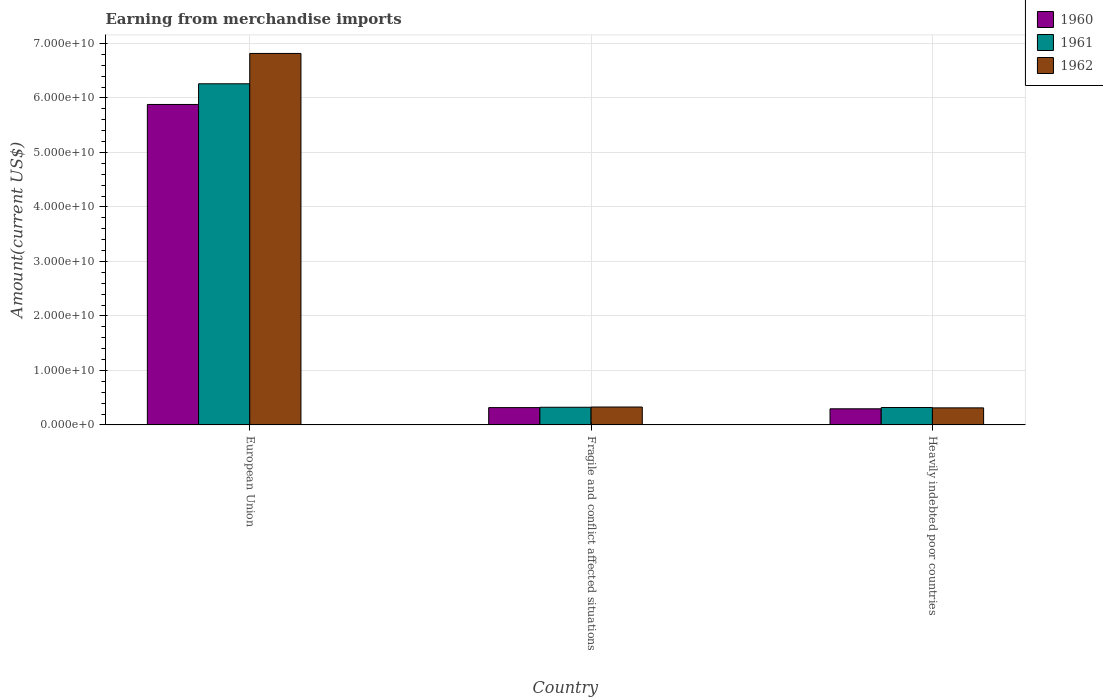How many groups of bars are there?
Your answer should be very brief. 3. Are the number of bars per tick equal to the number of legend labels?
Offer a very short reply. Yes. What is the amount earned from merchandise imports in 1962 in European Union?
Offer a terse response. 6.82e+1. Across all countries, what is the maximum amount earned from merchandise imports in 1960?
Keep it short and to the point. 5.88e+1. Across all countries, what is the minimum amount earned from merchandise imports in 1962?
Make the answer very short. 3.13e+09. In which country was the amount earned from merchandise imports in 1961 minimum?
Give a very brief answer. Heavily indebted poor countries. What is the total amount earned from merchandise imports in 1960 in the graph?
Your answer should be compact. 6.49e+1. What is the difference between the amount earned from merchandise imports in 1961 in European Union and that in Fragile and conflict affected situations?
Keep it short and to the point. 5.94e+1. What is the difference between the amount earned from merchandise imports in 1962 in European Union and the amount earned from merchandise imports in 1961 in Heavily indebted poor countries?
Provide a short and direct response. 6.50e+1. What is the average amount earned from merchandise imports in 1960 per country?
Your response must be concise. 2.16e+1. What is the difference between the amount earned from merchandise imports of/in 1962 and amount earned from merchandise imports of/in 1961 in European Union?
Keep it short and to the point. 5.56e+09. In how many countries, is the amount earned from merchandise imports in 1961 greater than 24000000000 US$?
Offer a terse response. 1. What is the ratio of the amount earned from merchandise imports in 1961 in European Union to that in Heavily indebted poor countries?
Offer a very short reply. 19.62. What is the difference between the highest and the second highest amount earned from merchandise imports in 1961?
Keep it short and to the point. -5.94e+1. What is the difference between the highest and the lowest amount earned from merchandise imports in 1961?
Give a very brief answer. 5.94e+1. Is it the case that in every country, the sum of the amount earned from merchandise imports in 1960 and amount earned from merchandise imports in 1962 is greater than the amount earned from merchandise imports in 1961?
Ensure brevity in your answer.  Yes. Are all the bars in the graph horizontal?
Keep it short and to the point. No. Does the graph contain any zero values?
Offer a terse response. No. Does the graph contain grids?
Your response must be concise. Yes. What is the title of the graph?
Offer a terse response. Earning from merchandise imports. What is the label or title of the Y-axis?
Your response must be concise. Amount(current US$). What is the Amount(current US$) of 1960 in European Union?
Your response must be concise. 5.88e+1. What is the Amount(current US$) of 1961 in European Union?
Offer a terse response. 6.26e+1. What is the Amount(current US$) in 1962 in European Union?
Provide a succinct answer. 6.82e+1. What is the Amount(current US$) in 1960 in Fragile and conflict affected situations?
Offer a terse response. 3.17e+09. What is the Amount(current US$) of 1961 in Fragile and conflict affected situations?
Your answer should be very brief. 3.24e+09. What is the Amount(current US$) in 1962 in Fragile and conflict affected situations?
Provide a short and direct response. 3.28e+09. What is the Amount(current US$) in 1960 in Heavily indebted poor countries?
Ensure brevity in your answer.  2.96e+09. What is the Amount(current US$) in 1961 in Heavily indebted poor countries?
Provide a succinct answer. 3.19e+09. What is the Amount(current US$) in 1962 in Heavily indebted poor countries?
Your answer should be compact. 3.13e+09. Across all countries, what is the maximum Amount(current US$) in 1960?
Keep it short and to the point. 5.88e+1. Across all countries, what is the maximum Amount(current US$) of 1961?
Keep it short and to the point. 6.26e+1. Across all countries, what is the maximum Amount(current US$) in 1962?
Make the answer very short. 6.82e+1. Across all countries, what is the minimum Amount(current US$) in 1960?
Your answer should be very brief. 2.96e+09. Across all countries, what is the minimum Amount(current US$) in 1961?
Offer a very short reply. 3.19e+09. Across all countries, what is the minimum Amount(current US$) in 1962?
Provide a short and direct response. 3.13e+09. What is the total Amount(current US$) of 1960 in the graph?
Provide a succinct answer. 6.49e+1. What is the total Amount(current US$) of 1961 in the graph?
Make the answer very short. 6.90e+1. What is the total Amount(current US$) in 1962 in the graph?
Provide a succinct answer. 7.46e+1. What is the difference between the Amount(current US$) in 1960 in European Union and that in Fragile and conflict affected situations?
Provide a short and direct response. 5.56e+1. What is the difference between the Amount(current US$) in 1961 in European Union and that in Fragile and conflict affected situations?
Ensure brevity in your answer.  5.94e+1. What is the difference between the Amount(current US$) in 1962 in European Union and that in Fragile and conflict affected situations?
Keep it short and to the point. 6.49e+1. What is the difference between the Amount(current US$) of 1960 in European Union and that in Heavily indebted poor countries?
Your response must be concise. 5.59e+1. What is the difference between the Amount(current US$) in 1961 in European Union and that in Heavily indebted poor countries?
Give a very brief answer. 5.94e+1. What is the difference between the Amount(current US$) of 1962 in European Union and that in Heavily indebted poor countries?
Ensure brevity in your answer.  6.50e+1. What is the difference between the Amount(current US$) of 1960 in Fragile and conflict affected situations and that in Heavily indebted poor countries?
Your answer should be very brief. 2.18e+08. What is the difference between the Amount(current US$) in 1961 in Fragile and conflict affected situations and that in Heavily indebted poor countries?
Your answer should be compact. 4.90e+07. What is the difference between the Amount(current US$) of 1962 in Fragile and conflict affected situations and that in Heavily indebted poor countries?
Offer a very short reply. 1.55e+08. What is the difference between the Amount(current US$) in 1960 in European Union and the Amount(current US$) in 1961 in Fragile and conflict affected situations?
Provide a succinct answer. 5.56e+1. What is the difference between the Amount(current US$) in 1960 in European Union and the Amount(current US$) in 1962 in Fragile and conflict affected situations?
Your answer should be compact. 5.55e+1. What is the difference between the Amount(current US$) of 1961 in European Union and the Amount(current US$) of 1962 in Fragile and conflict affected situations?
Provide a short and direct response. 5.93e+1. What is the difference between the Amount(current US$) of 1960 in European Union and the Amount(current US$) of 1961 in Heavily indebted poor countries?
Offer a terse response. 5.56e+1. What is the difference between the Amount(current US$) of 1960 in European Union and the Amount(current US$) of 1962 in Heavily indebted poor countries?
Give a very brief answer. 5.57e+1. What is the difference between the Amount(current US$) in 1961 in European Union and the Amount(current US$) in 1962 in Heavily indebted poor countries?
Provide a succinct answer. 5.95e+1. What is the difference between the Amount(current US$) in 1960 in Fragile and conflict affected situations and the Amount(current US$) in 1961 in Heavily indebted poor countries?
Give a very brief answer. -1.74e+07. What is the difference between the Amount(current US$) in 1960 in Fragile and conflict affected situations and the Amount(current US$) in 1962 in Heavily indebted poor countries?
Your answer should be compact. 4.64e+07. What is the difference between the Amount(current US$) of 1961 in Fragile and conflict affected situations and the Amount(current US$) of 1962 in Heavily indebted poor countries?
Provide a succinct answer. 1.13e+08. What is the average Amount(current US$) of 1960 per country?
Your response must be concise. 2.16e+1. What is the average Amount(current US$) of 1961 per country?
Your answer should be compact. 2.30e+1. What is the average Amount(current US$) in 1962 per country?
Your response must be concise. 2.49e+1. What is the difference between the Amount(current US$) in 1960 and Amount(current US$) in 1961 in European Union?
Your answer should be very brief. -3.80e+09. What is the difference between the Amount(current US$) in 1960 and Amount(current US$) in 1962 in European Union?
Provide a short and direct response. -9.36e+09. What is the difference between the Amount(current US$) in 1961 and Amount(current US$) in 1962 in European Union?
Your answer should be compact. -5.56e+09. What is the difference between the Amount(current US$) of 1960 and Amount(current US$) of 1961 in Fragile and conflict affected situations?
Your response must be concise. -6.64e+07. What is the difference between the Amount(current US$) in 1960 and Amount(current US$) in 1962 in Fragile and conflict affected situations?
Ensure brevity in your answer.  -1.09e+08. What is the difference between the Amount(current US$) of 1961 and Amount(current US$) of 1962 in Fragile and conflict affected situations?
Make the answer very short. -4.24e+07. What is the difference between the Amount(current US$) in 1960 and Amount(current US$) in 1961 in Heavily indebted poor countries?
Your answer should be compact. -2.35e+08. What is the difference between the Amount(current US$) of 1960 and Amount(current US$) of 1962 in Heavily indebted poor countries?
Give a very brief answer. -1.71e+08. What is the difference between the Amount(current US$) of 1961 and Amount(current US$) of 1962 in Heavily indebted poor countries?
Your response must be concise. 6.38e+07. What is the ratio of the Amount(current US$) in 1960 in European Union to that in Fragile and conflict affected situations?
Offer a very short reply. 18.53. What is the ratio of the Amount(current US$) in 1961 in European Union to that in Fragile and conflict affected situations?
Offer a very short reply. 19.32. What is the ratio of the Amount(current US$) of 1962 in European Union to that in Fragile and conflict affected situations?
Your response must be concise. 20.77. What is the ratio of the Amount(current US$) of 1960 in European Union to that in Heavily indebted poor countries?
Your answer should be very brief. 19.9. What is the ratio of the Amount(current US$) of 1961 in European Union to that in Heavily indebted poor countries?
Make the answer very short. 19.62. What is the ratio of the Amount(current US$) of 1962 in European Union to that in Heavily indebted poor countries?
Keep it short and to the point. 21.8. What is the ratio of the Amount(current US$) of 1960 in Fragile and conflict affected situations to that in Heavily indebted poor countries?
Provide a short and direct response. 1.07. What is the ratio of the Amount(current US$) in 1961 in Fragile and conflict affected situations to that in Heavily indebted poor countries?
Your answer should be compact. 1.02. What is the ratio of the Amount(current US$) in 1962 in Fragile and conflict affected situations to that in Heavily indebted poor countries?
Ensure brevity in your answer.  1.05. What is the difference between the highest and the second highest Amount(current US$) in 1960?
Provide a succinct answer. 5.56e+1. What is the difference between the highest and the second highest Amount(current US$) in 1961?
Your answer should be compact. 5.94e+1. What is the difference between the highest and the second highest Amount(current US$) in 1962?
Provide a short and direct response. 6.49e+1. What is the difference between the highest and the lowest Amount(current US$) in 1960?
Your response must be concise. 5.59e+1. What is the difference between the highest and the lowest Amount(current US$) in 1961?
Ensure brevity in your answer.  5.94e+1. What is the difference between the highest and the lowest Amount(current US$) of 1962?
Offer a very short reply. 6.50e+1. 